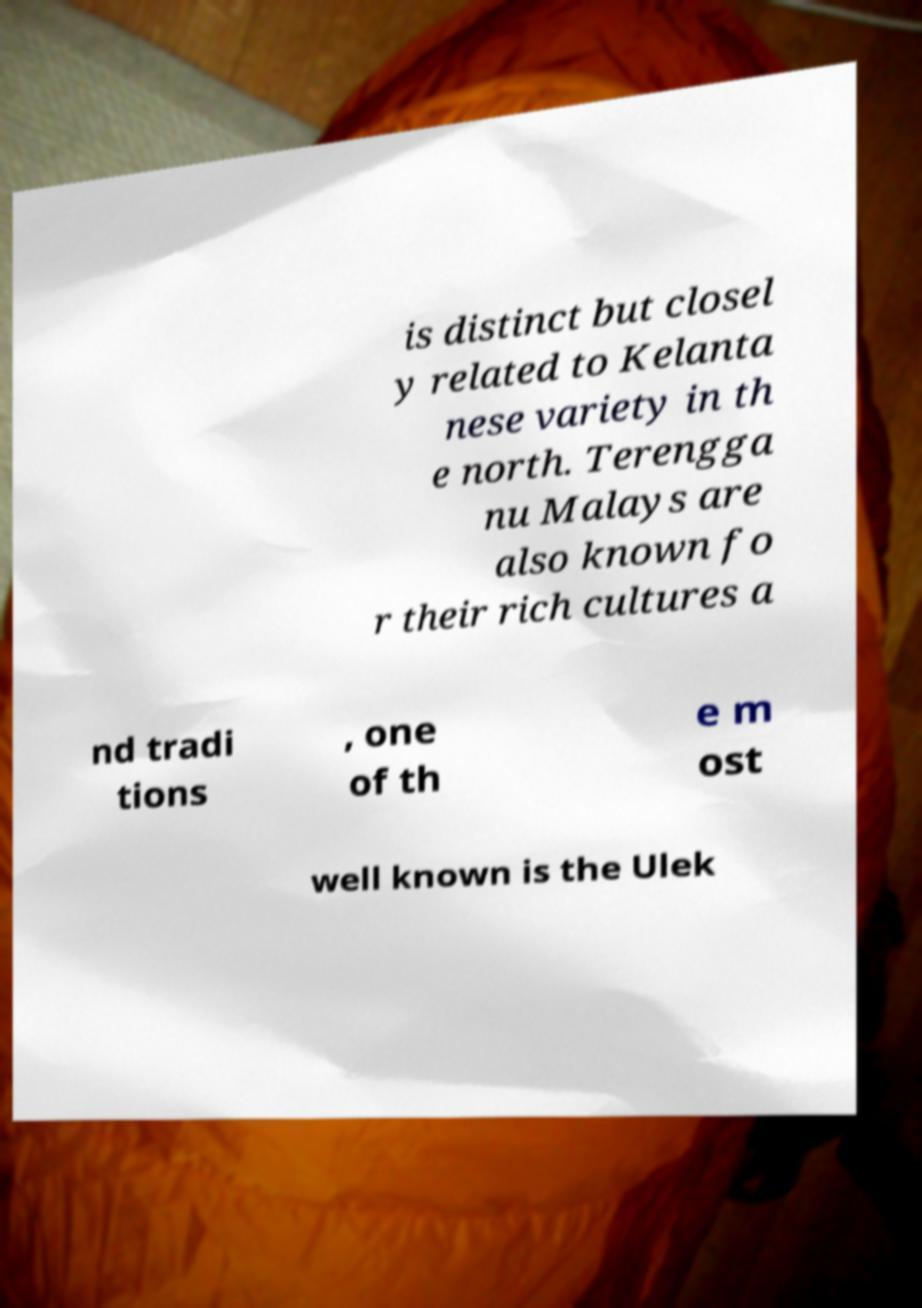Could you assist in decoding the text presented in this image and type it out clearly? is distinct but closel y related to Kelanta nese variety in th e north. Terengga nu Malays are also known fo r their rich cultures a nd tradi tions , one of th e m ost well known is the Ulek 